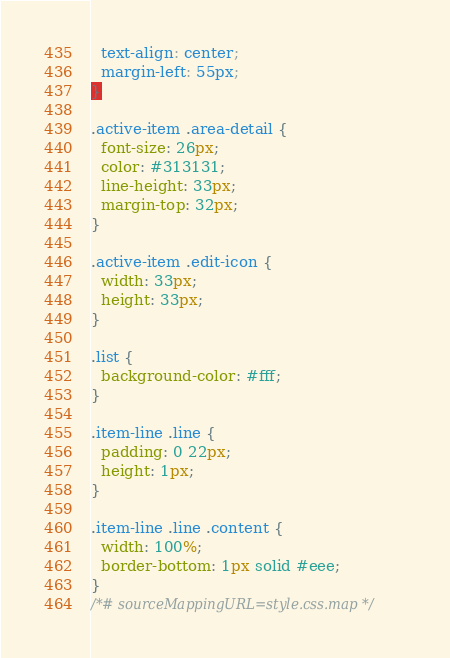<code> <loc_0><loc_0><loc_500><loc_500><_CSS_>  text-align: center;
  margin-left: 55px;
}

.active-item .area-detail {
  font-size: 26px;
  color: #313131;
  line-height: 33px;
  margin-top: 32px;
}

.active-item .edit-icon {
  width: 33px;
  height: 33px;
}

.list {
  background-color: #fff;
}

.item-line .line {
  padding: 0 22px;
  height: 1px;
}

.item-line .line .content {
  width: 100%;
  border-bottom: 1px solid #eee;
}
/*# sourceMappingURL=style.css.map */</code> 